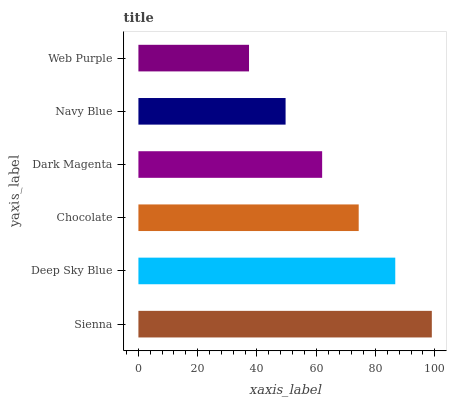Is Web Purple the minimum?
Answer yes or no. Yes. Is Sienna the maximum?
Answer yes or no. Yes. Is Deep Sky Blue the minimum?
Answer yes or no. No. Is Deep Sky Blue the maximum?
Answer yes or no. No. Is Sienna greater than Deep Sky Blue?
Answer yes or no. Yes. Is Deep Sky Blue less than Sienna?
Answer yes or no. Yes. Is Deep Sky Blue greater than Sienna?
Answer yes or no. No. Is Sienna less than Deep Sky Blue?
Answer yes or no. No. Is Chocolate the high median?
Answer yes or no. Yes. Is Dark Magenta the low median?
Answer yes or no. Yes. Is Navy Blue the high median?
Answer yes or no. No. Is Navy Blue the low median?
Answer yes or no. No. 